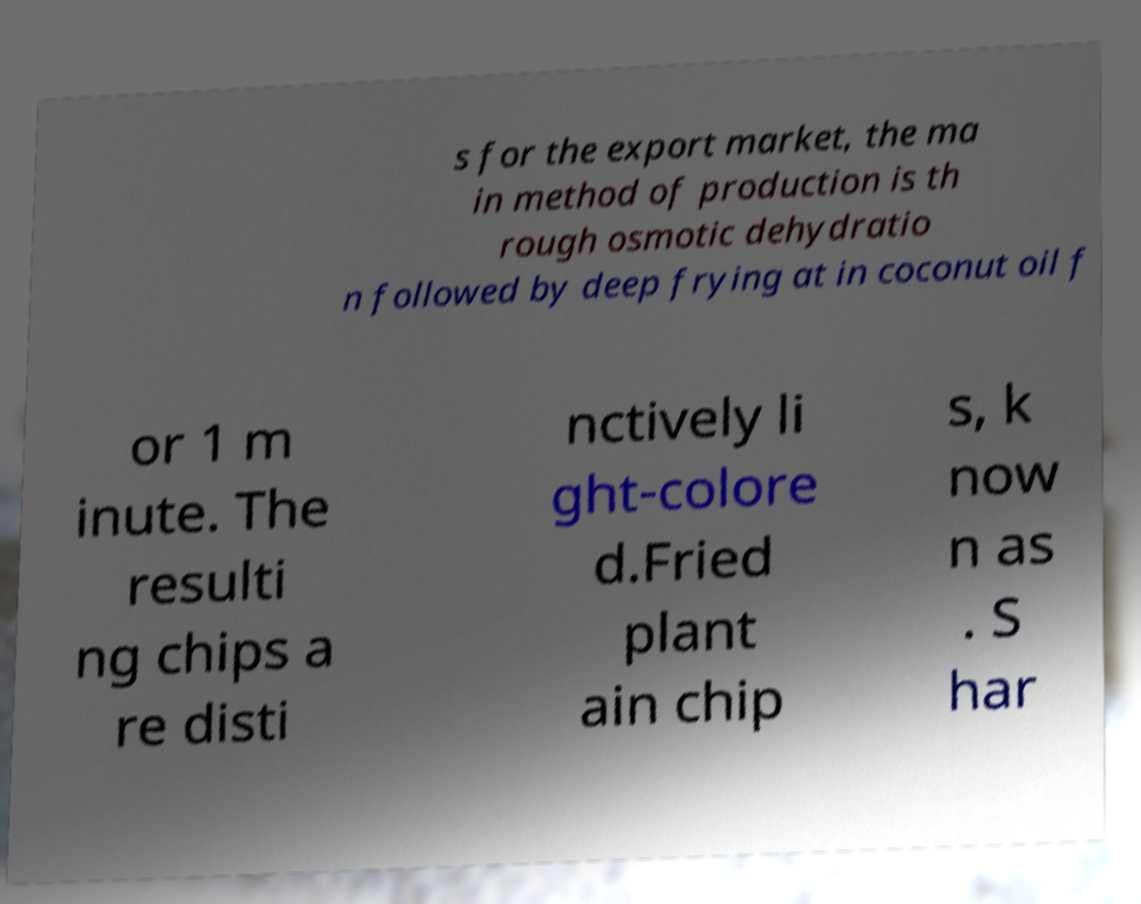For documentation purposes, I need the text within this image transcribed. Could you provide that? s for the export market, the ma in method of production is th rough osmotic dehydratio n followed by deep frying at in coconut oil f or 1 m inute. The resulti ng chips a re disti nctively li ght-colore d.Fried plant ain chip s, k now n as . S har 